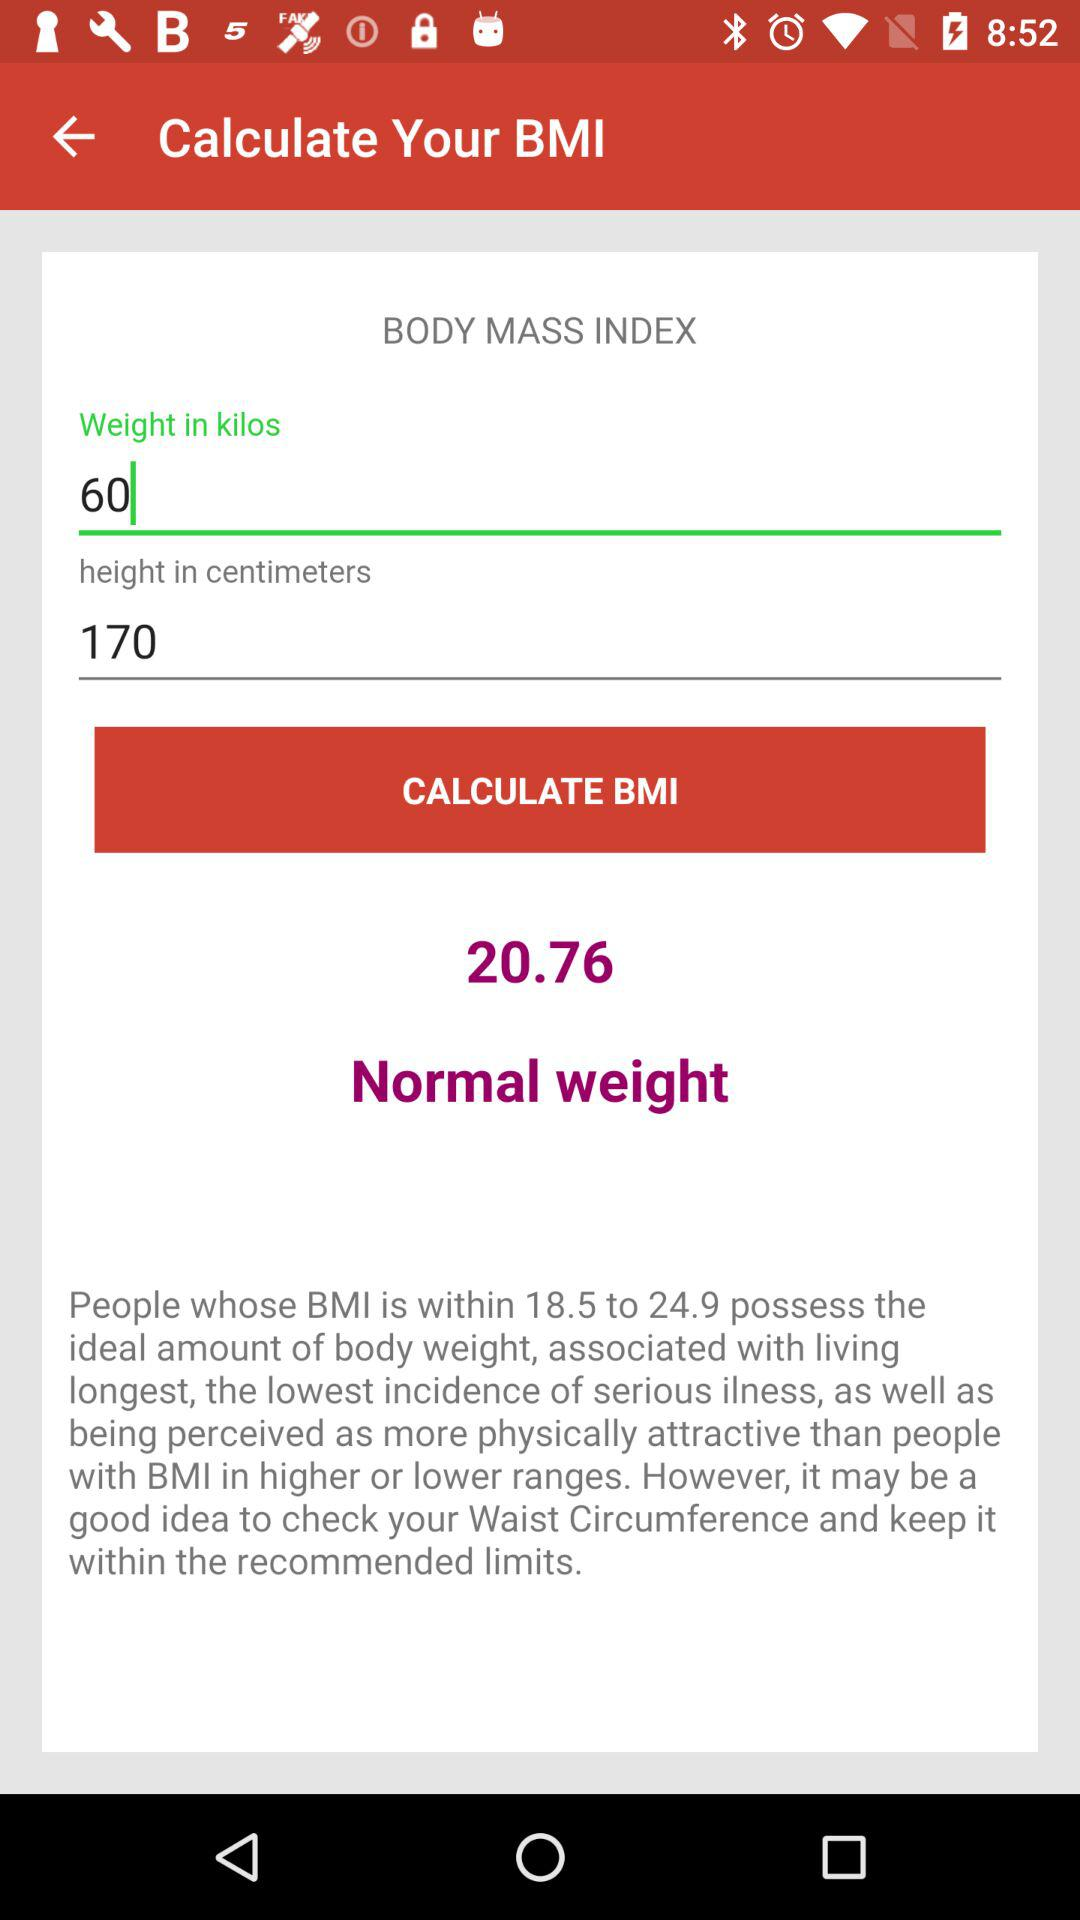What is my Body Mass Index (BMI)?
Answer the question using a single word or phrase. 20.76 